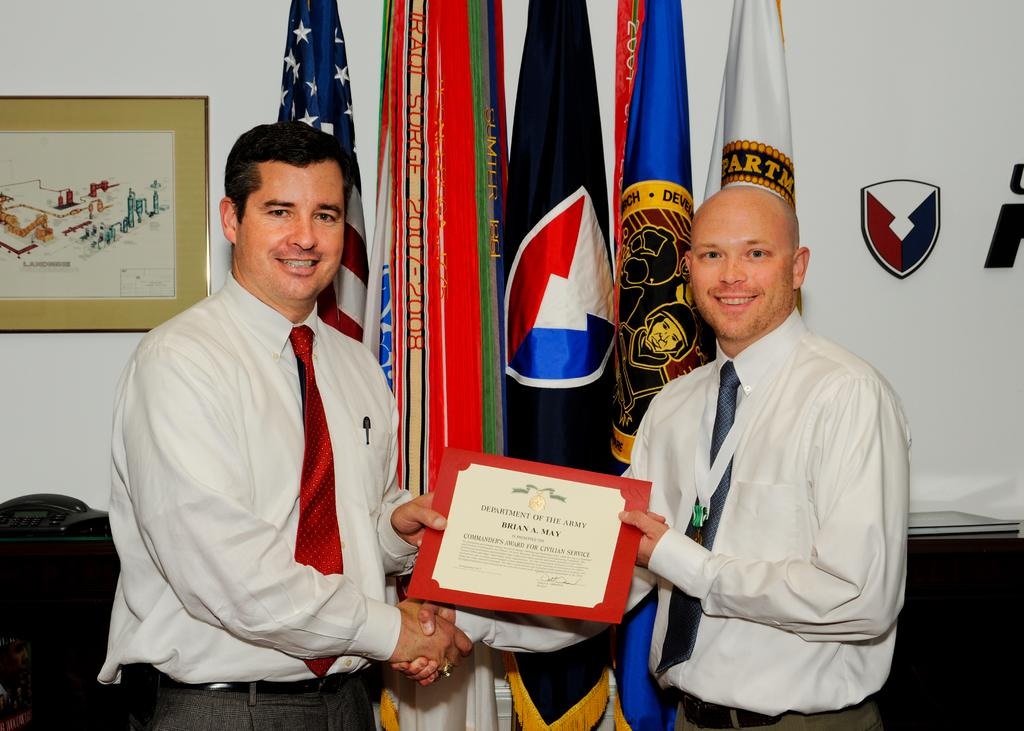What is the main subject of the image? The main subject of the image is the persons standing in the center. What can be seen in the background of the image? In the background of the image, there is a photo frame and flags. What type of structure is visible in the background? There is a wall visible in the background. What day of the week is depicted in the image? The day of the week is not depicted in the image, as it does not show any specific date or time. 